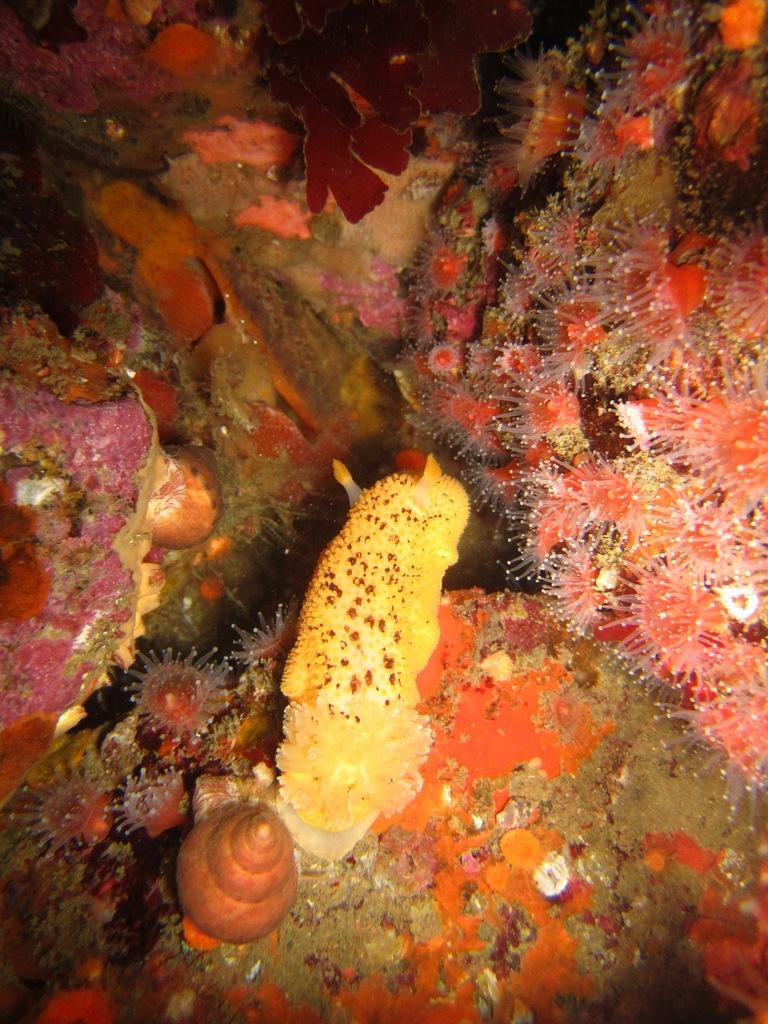What type of animals can be seen in the image? There are snails in the image. What type of underwater environment is visible in the image? There are coral reefs in the image. What is the name of the team that the snails are supporting in the image? There is no team or any indication of support for a team in the image; it simply features snails and coral reefs. 